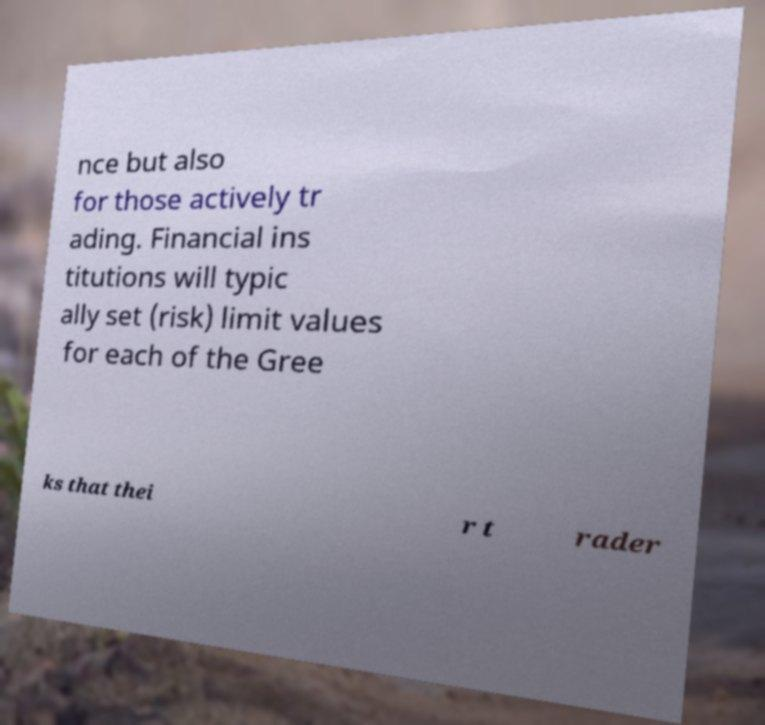Can you accurately transcribe the text from the provided image for me? nce but also for those actively tr ading. Financial ins titutions will typic ally set (risk) limit values for each of the Gree ks that thei r t rader 